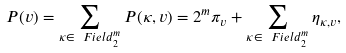Convert formula to latex. <formula><loc_0><loc_0><loc_500><loc_500>P ( v ) = \sum _ { \kappa \in \ F i e l d _ { 2 } ^ { m } } P ( \kappa , v ) = 2 ^ { m } \pi _ { v } + \sum _ { \kappa \in \ F i e l d _ { 2 } ^ { m } } \eta _ { \kappa , v } ,</formula> 